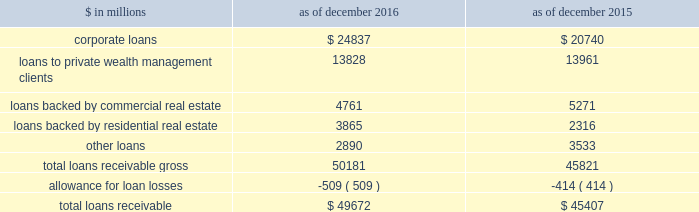The goldman sachs group , inc .
And subsidiaries notes to consolidated financial statements long-term debt instruments the aggregate contractual principal amount of long-term other secured financings for which the fair value option was elected exceeded the related fair value by $ 361 million and $ 362 million as of december 2016 and december 2015 , respectively .
The aggregate contractual principal amount of unsecured long-term borrowings for which the fair value option was elected exceeded the related fair value by $ 1.56 billion and $ 1.12 billion as of december 2016 and december 2015 , respectively .
The amounts above include both principal- and non-principal-protected long-term borrowings .
Impact of credit spreads on loans and lending commitments the estimated net gain attributable to changes in instrument-specific credit spreads on loans and lending commitments for which the fair value option was elected was $ 281 million for 2016 , $ 751 million for 2015 and $ 1.83 billion for 2014 , respectively .
The firm generally calculates the fair value of loans and lending commitments for which the fair value option is elected by discounting future cash flows at a rate which incorporates the instrument-specific credit spreads .
For floating-rate loans and lending commitments , substantially all changes in fair value are attributable to changes in instrument-specific credit spreads , whereas for fixed-rate loans and lending commitments , changes in fair value are also attributable to changes in interest rates .
Debt valuation adjustment the firm calculates the fair value of financial liabilities for which the fair value option is elected by discounting future cash flows at a rate which incorporates the firm 2019s credit spreads .
The net dva on such financial liabilities was a loss of $ 844 million ( $ 544 million , net of tax ) for 2016 and was included in 201cdebt valuation adjustment 201d in the consolidated statements of comprehensive income .
The gains/ ( losses ) reclassified to earnings from accumulated other comprehensive loss upon extinguishment of such financial liabilities were not material for 2016 .
Note 9 .
Loans receivable loans receivable is comprised of loans held for investment that are accounted for at amortized cost net of allowance for loan losses .
Interest on loans receivable is recognized over the life of the loan and is recorded on an accrual basis .
The table below presents details about loans receivable. .
As of december 2016 and december 2015 , the fair value of loans receivable was $ 49.80 billion and $ 45.19 billion , respectively .
As of december 2016 , had these loans been carried at fair value and included in the fair value hierarchy , $ 28.40 billion and $ 21.40 billion would have been classified in level 2 and level 3 , respectively .
As of december 2015 , had these loans been carried at fair value and included in the fair value hierarchy , $ 23.91 billion and $ 21.28 billion would have been classified in level 2 and level 3 , respectively .
The firm also extends lending commitments that are held for investment and accounted for on an accrual basis .
As of december 2016 and december 2015 , such lending commitments were $ 98.05 billion and $ 93.92 billion , respectively .
Substantially all of these commitments were extended to corporate borrowers and were primarily related to the firm 2019s relationship lending activities .
The carrying value and the estimated fair value of such lending commitments were liabilities of $ 327 million and $ 2.55 billion , respectively , as of december 2016 , and $ 291 million and $ 3.32 billion , respectively , as of december 2015 .
As of december 2016 , had these lending commitments been carried at fair value and included in the fair value hierarchy , $ 1.10 billion and $ 1.45 billion would have been classified in level 2 and level 3 , respectively .
As of december 2015 , had these lending commitments been carried at fair value and included in the fair value hierarchy , $ 1.35 billion and $ 1.97 billion would have been classified in level 2 and level 3 , respectively .
Goldman sachs 2016 form 10-k 147 .
What percentage of total loans receivable gross in 2015 were loans backed by commercial real estate? 
Computations: (5271 / 45821)
Answer: 0.11503. 